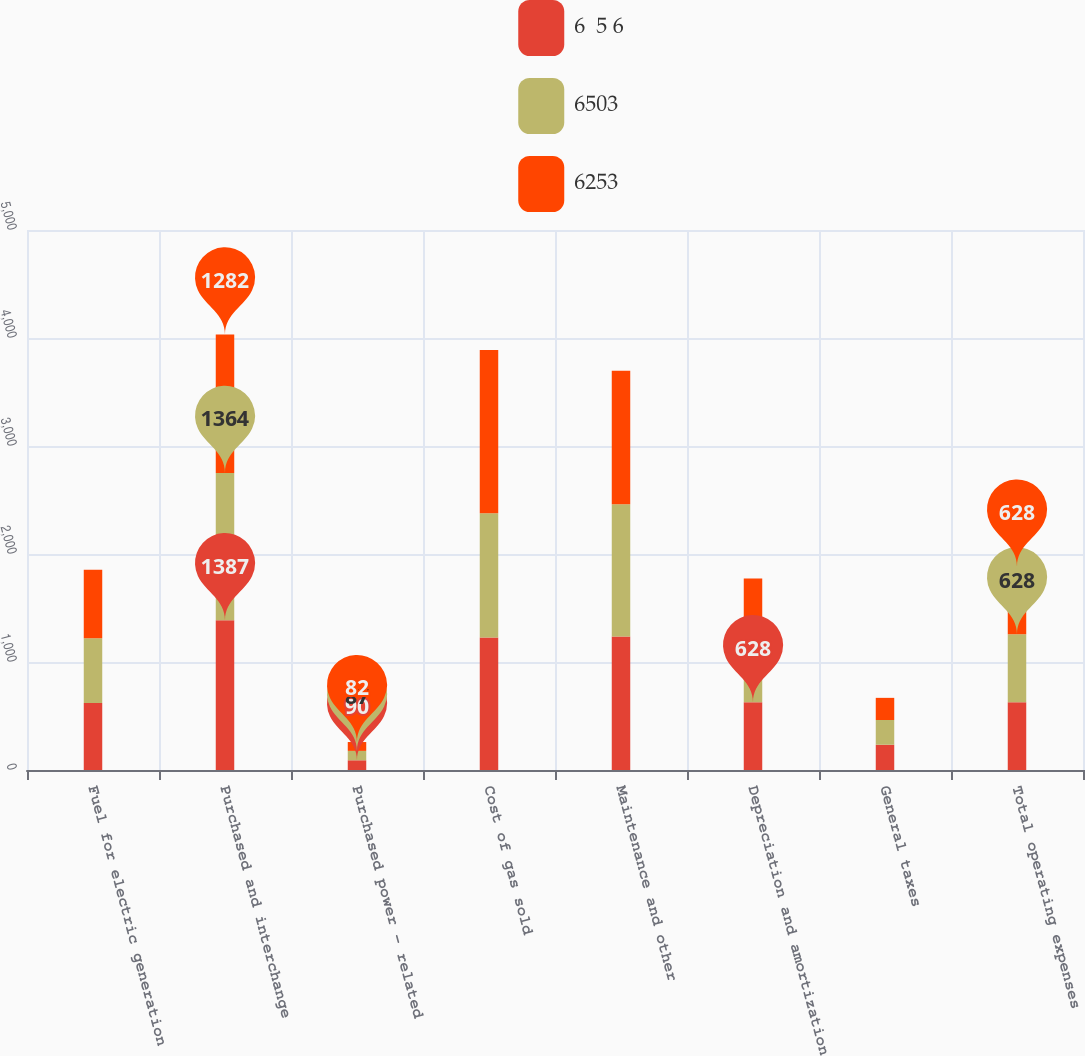Convert chart. <chart><loc_0><loc_0><loc_500><loc_500><stacked_bar_chart><ecel><fcel>Fuel for electric generation<fcel>Purchased and interchange<fcel>Purchased power - related<fcel>Cost of gas sold<fcel>Maintenance and other<fcel>Depreciation and amortization<fcel>General taxes<fcel>Total operating expenses<nl><fcel>6  5 6<fcel>621<fcel>1387<fcel>90<fcel>1228<fcel>1236<fcel>628<fcel>234<fcel>628<nl><fcel>6503<fcel>598<fcel>1364<fcel>87<fcel>1150<fcel>1224<fcel>598<fcel>229<fcel>628<nl><fcel>6253<fcel>636<fcel>1282<fcel>82<fcel>1512<fcel>1237<fcel>546<fcel>205<fcel>628<nl></chart> 